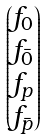<formula> <loc_0><loc_0><loc_500><loc_500>\begin{pmatrix} f _ { 0 } \\ f _ { \bar { 0 } } \\ f _ { p } \\ f _ { \bar { p } } \end{pmatrix}</formula> 